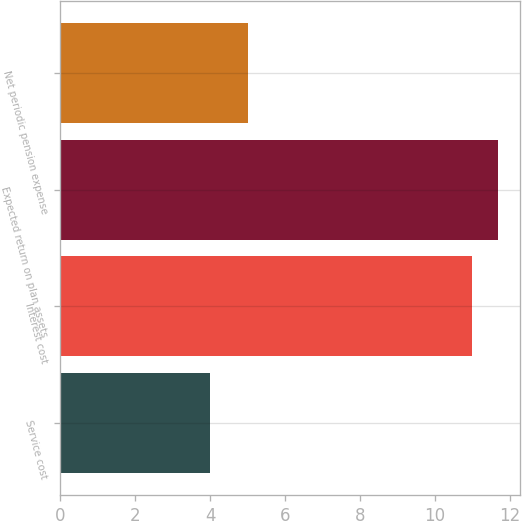Convert chart to OTSL. <chart><loc_0><loc_0><loc_500><loc_500><bar_chart><fcel>Service cost<fcel>Interest cost<fcel>Expected return on plan assets<fcel>Net periodic pension expense<nl><fcel>4<fcel>11<fcel>11.7<fcel>5<nl></chart> 